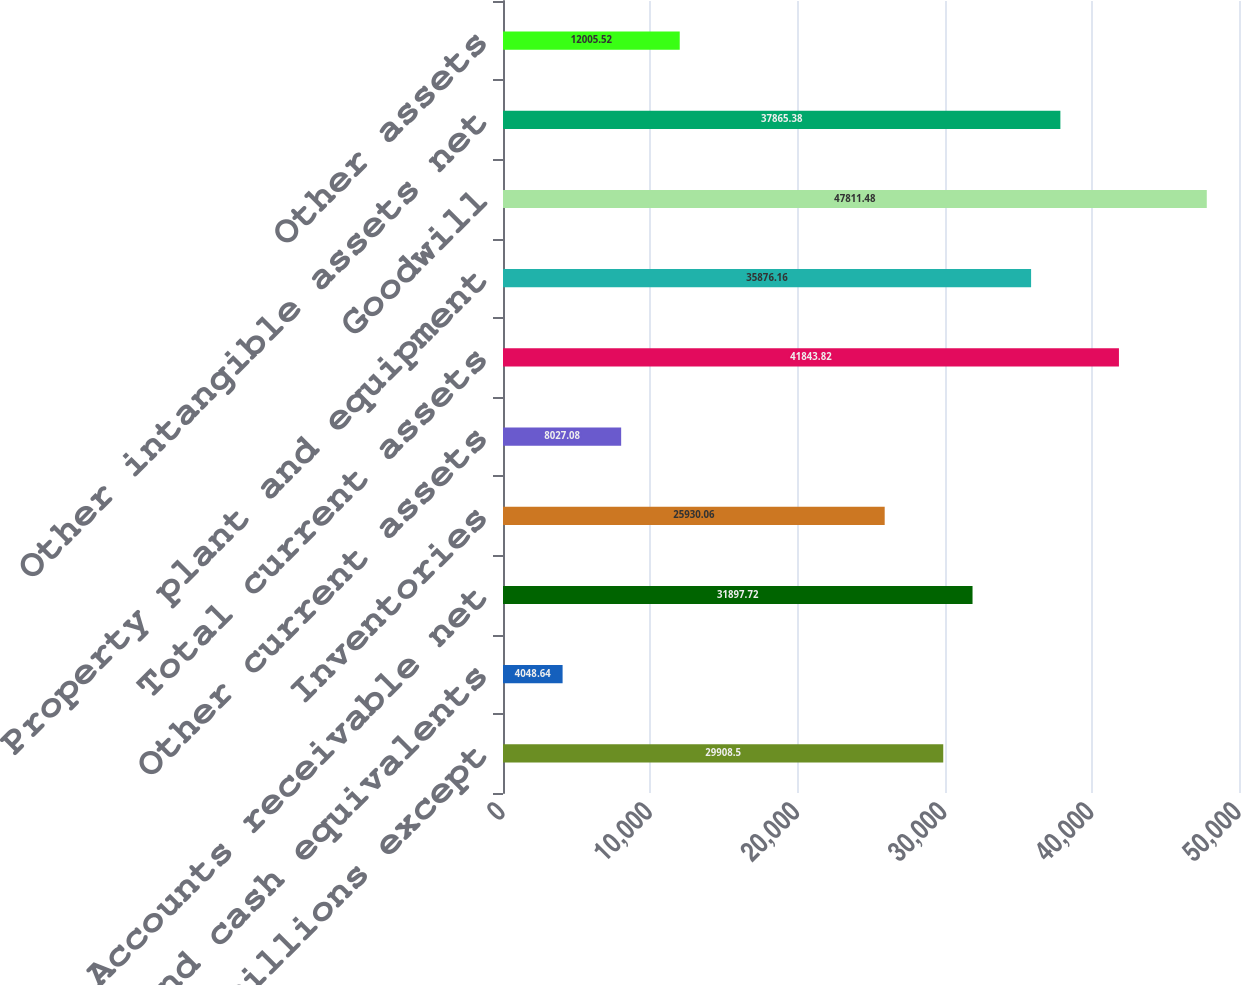<chart> <loc_0><loc_0><loc_500><loc_500><bar_chart><fcel>December 31 (millions except<fcel>Cash and cash equivalents<fcel>Accounts receivable net<fcel>Inventories<fcel>Other current assets<fcel>Total current assets<fcel>Property plant and equipment<fcel>Goodwill<fcel>Other intangible assets net<fcel>Other assets<nl><fcel>29908.5<fcel>4048.64<fcel>31897.7<fcel>25930.1<fcel>8027.08<fcel>41843.8<fcel>35876.2<fcel>47811.5<fcel>37865.4<fcel>12005.5<nl></chart> 